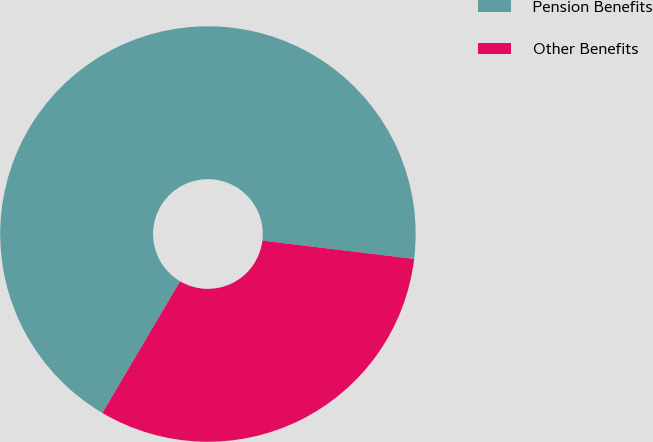Convert chart. <chart><loc_0><loc_0><loc_500><loc_500><pie_chart><fcel>Pension Benefits<fcel>Other Benefits<nl><fcel>68.43%<fcel>31.57%<nl></chart> 